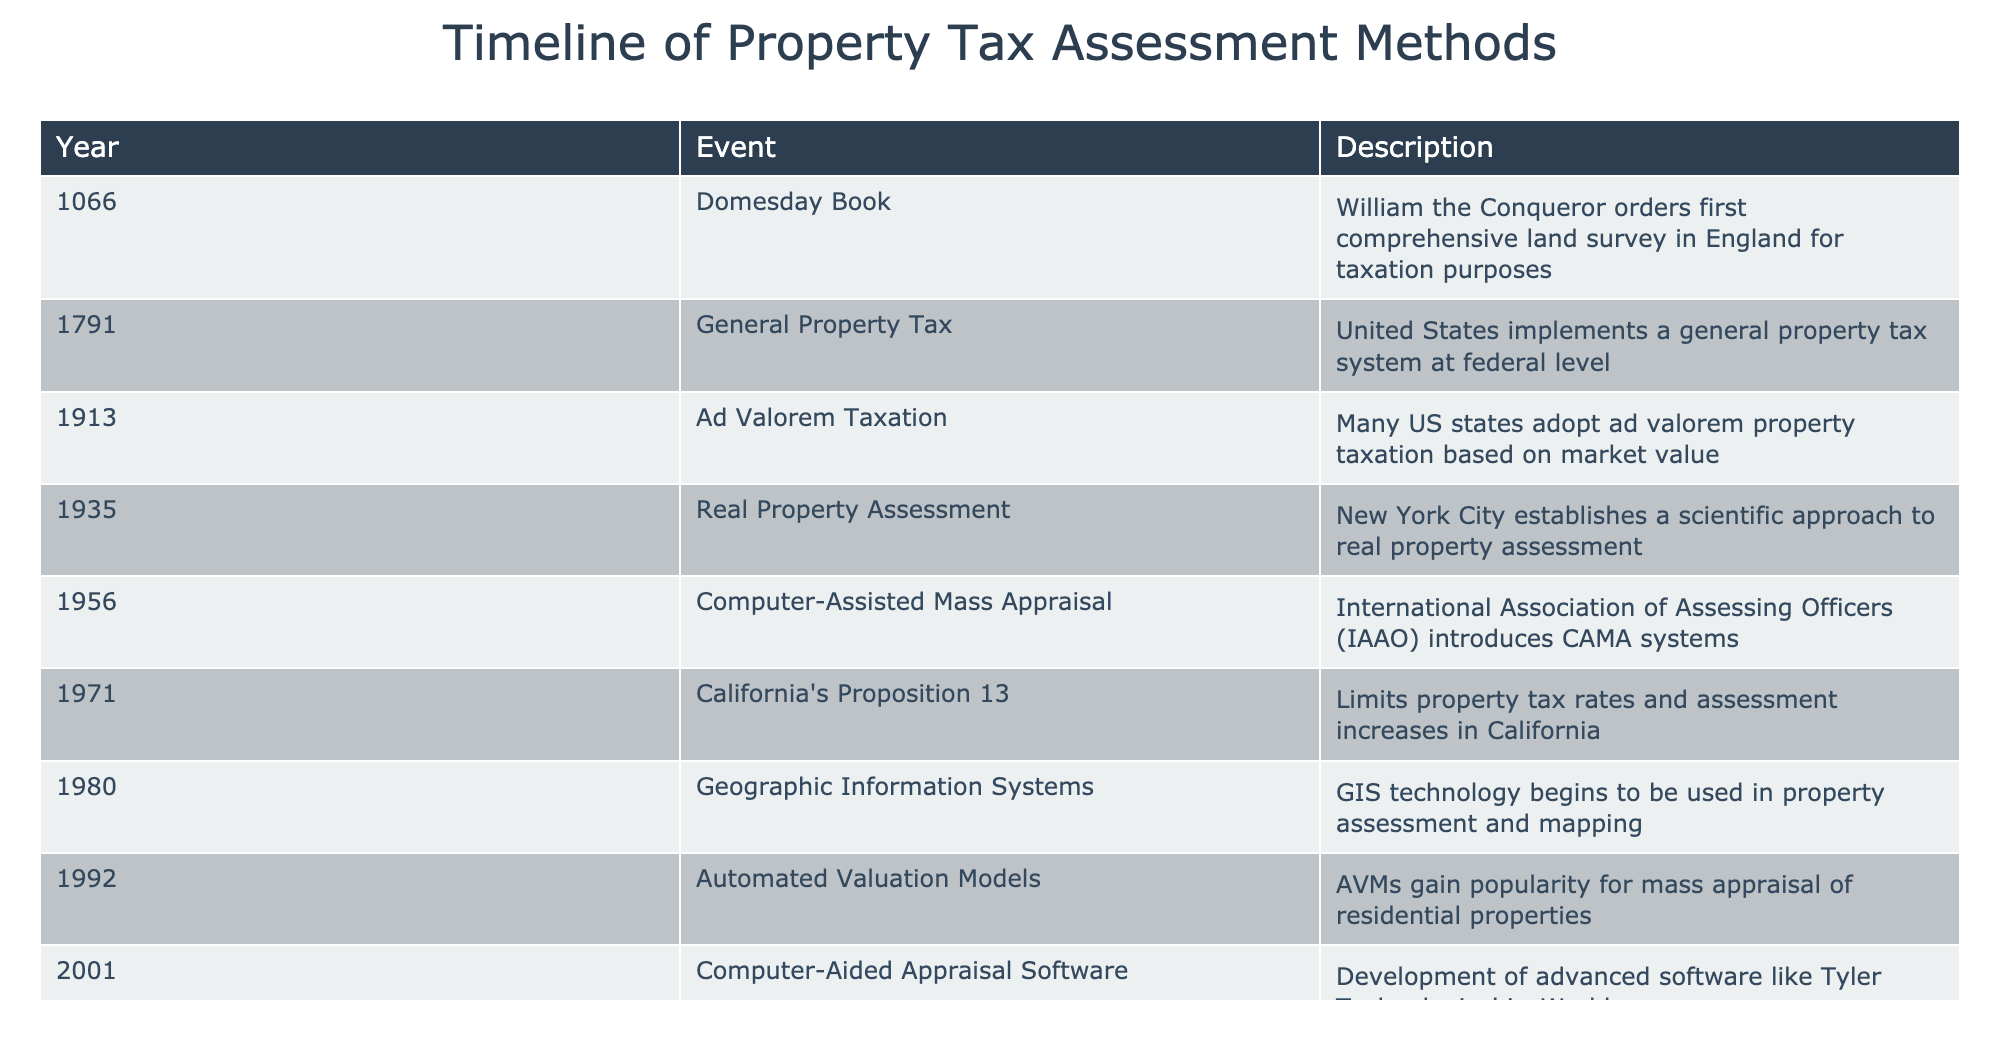What year was the Domesday Book completed? The Domesday Book was completed in 1066, as listed in the table under the "Year" column corresponding to the "Event" of the Domesday Book.
Answer: 1066 Which event marks the introduction of a general property tax system in the United States? The event that marks the introduction of a general property tax system in the U.S. is in 1791, as noted in the table.
Answer: General Property Tax in 1791 How many years elapsed between the establishment of ad valorem taxation and the introduction of automated valuation models? Ad valorem taxation was established in 1913, and automated valuation models were introduced in 1992. The difference in years is 1992 - 1913 = 79 years.
Answer: 79 years Was California's Proposition 13 implemented before or after the introduction of Geographic Information Systems in property assessment? Proposition 13 was implemented in 1971, while GIS technology was introduced in 1980, as seen in the table. Therefore, Proposition 13 was implemented before GIS.
Answer: Before List the last two technological advancements mentioned in the timeline. The last two advancements are the use of drones for property inspection in 2015 and the incorporation of artificial intelligence in valuation in 2020, as shown in the table.
Answer: Drones in 2015 and AI in 2020 What is the difference in years between the introduction of computer-aided appraisal software and the use of drones? Computer-aided appraisal software was introduced in 2001, and drones for property assessment began being used in 2015. The difference is 2015 - 2001 = 14 years.
Answer: 14 years Is the year 1935 associated with a significant event related to property assessment? Yes, the year 1935 is associated with the establishment of a scientific approach to real property assessment in New York City.
Answer: Yes Which event happened first: the introduction of Geographic Information Systems or California's Proposition 13? California's Proposition 13 occurred in 1971, while Geographic Information Systems began being used in 1980. Since 1971 is earlier than 1980, Proposition 13 happened first.
Answer: Proposition 13 happened first 